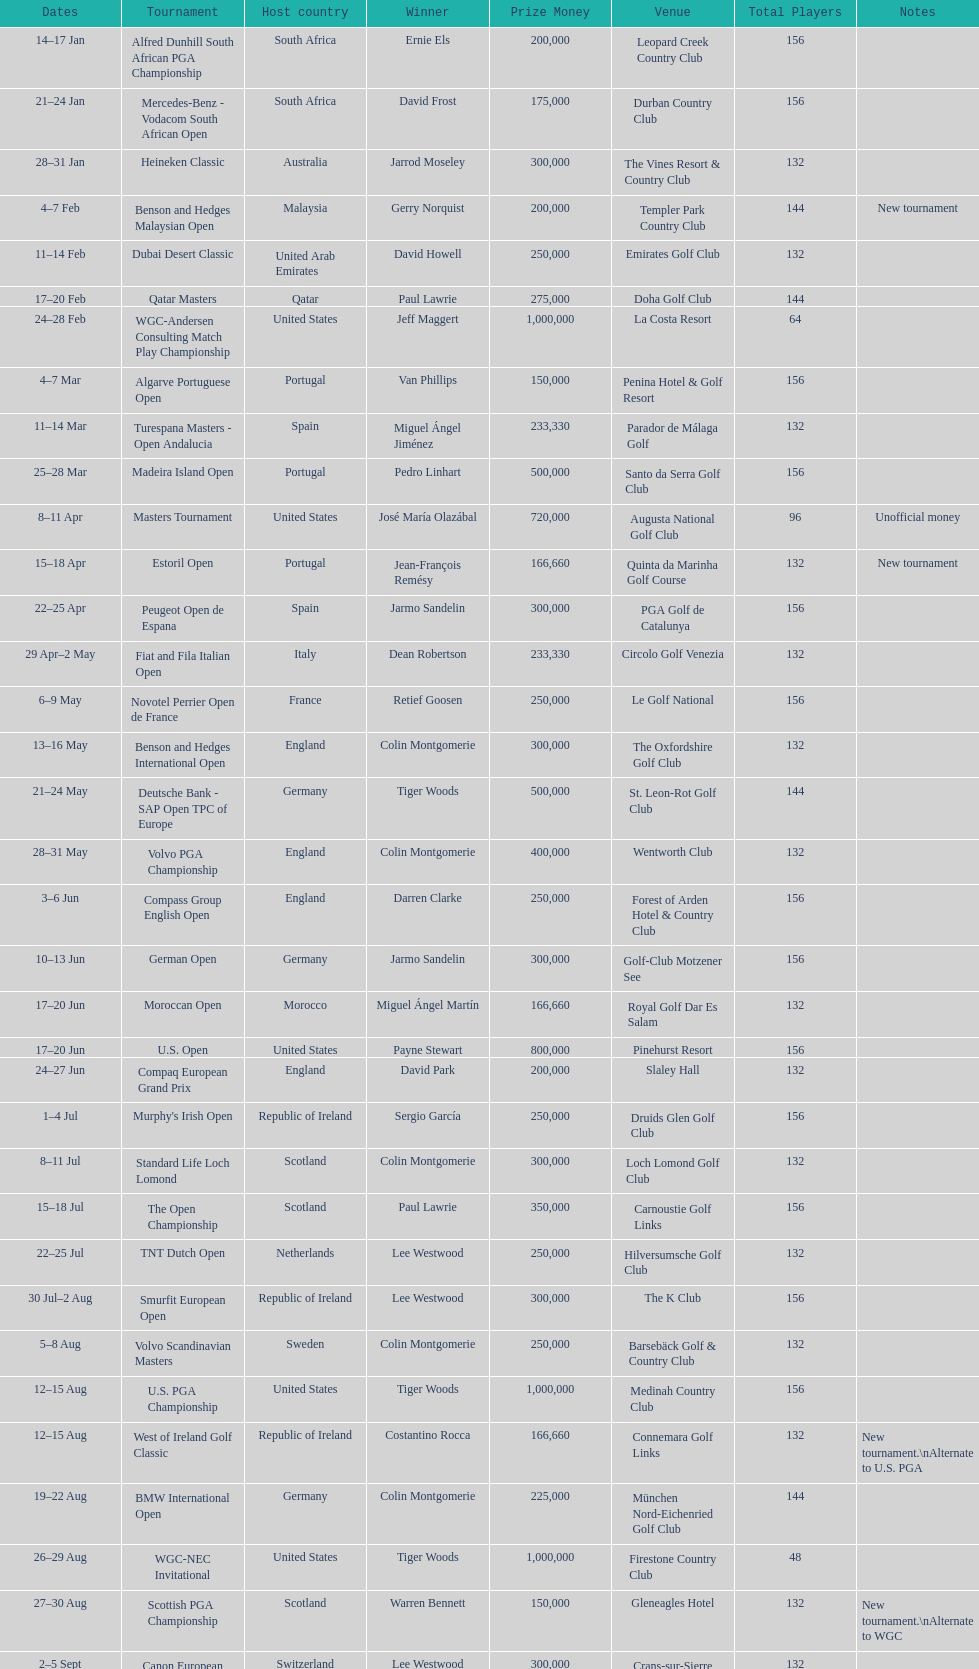How many tournaments began before aug 15th 31. 